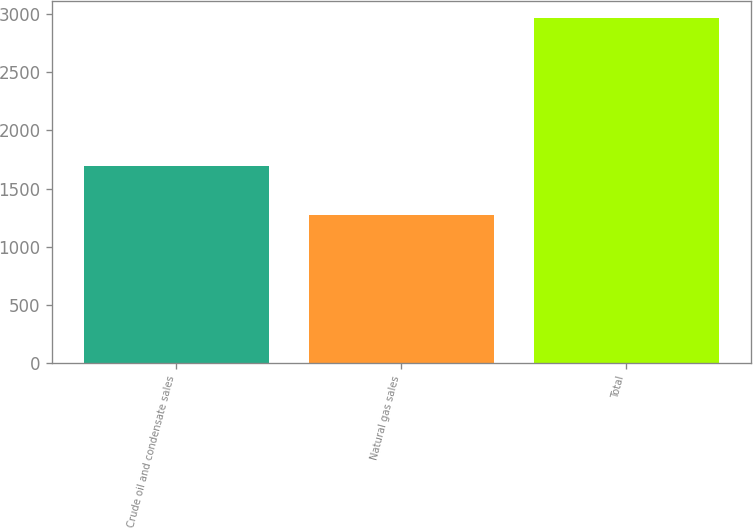Convert chart to OTSL. <chart><loc_0><loc_0><loc_500><loc_500><bar_chart><fcel>Crude oil and condensate sales<fcel>Natural gas sales<fcel>Total<nl><fcel>1694<fcel>1272<fcel>2966<nl></chart> 